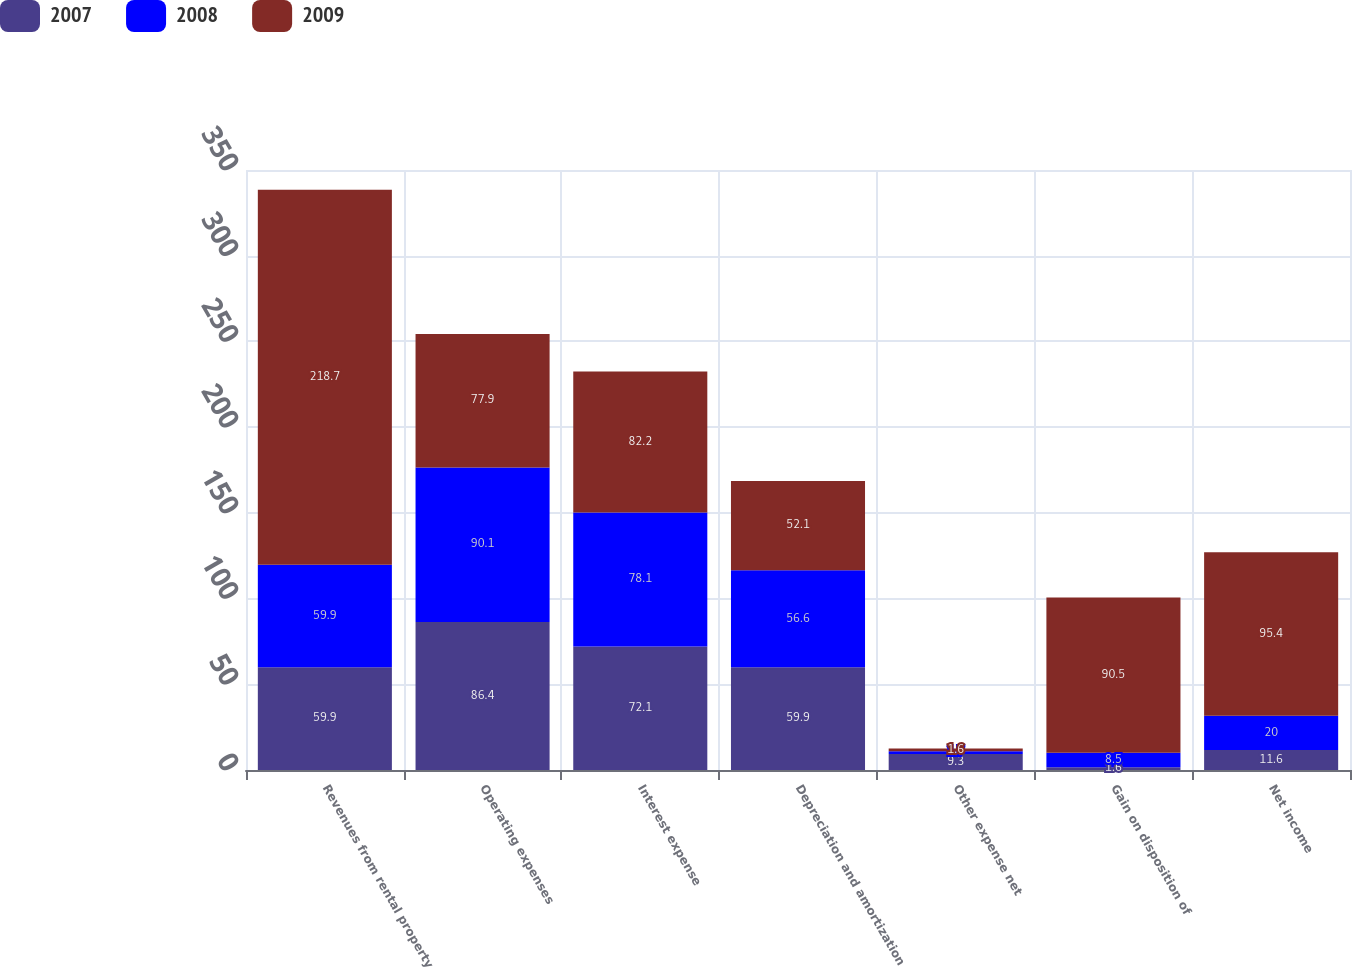Convert chart. <chart><loc_0><loc_0><loc_500><loc_500><stacked_bar_chart><ecel><fcel>Revenues from rental property<fcel>Operating expenses<fcel>Interest expense<fcel>Depreciation and amortization<fcel>Other expense net<fcel>Gain on disposition of<fcel>Net income<nl><fcel>2007<fcel>59.9<fcel>86.4<fcel>72.1<fcel>59.9<fcel>9.3<fcel>1.6<fcel>11.6<nl><fcel>2008<fcel>59.9<fcel>90.1<fcel>78.1<fcel>56.6<fcel>1.7<fcel>8.5<fcel>20<nl><fcel>2009<fcel>218.7<fcel>77.9<fcel>82.2<fcel>52.1<fcel>1.6<fcel>90.5<fcel>95.4<nl></chart> 